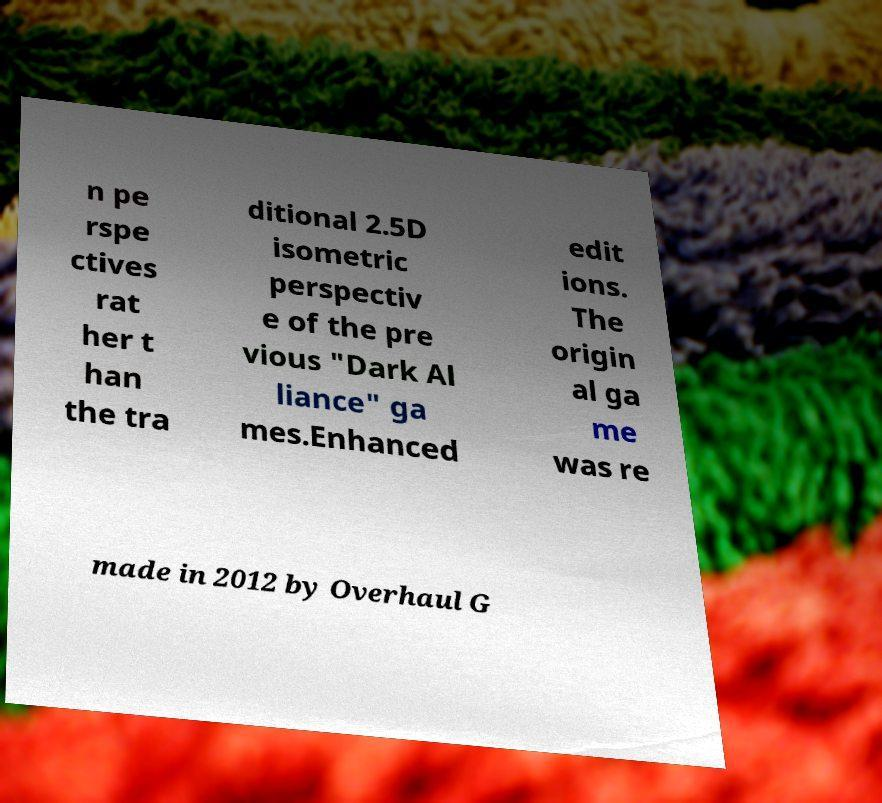Can you accurately transcribe the text from the provided image for me? n pe rspe ctives rat her t han the tra ditional 2.5D isometric perspectiv e of the pre vious "Dark Al liance" ga mes.Enhanced edit ions. The origin al ga me was re made in 2012 by Overhaul G 